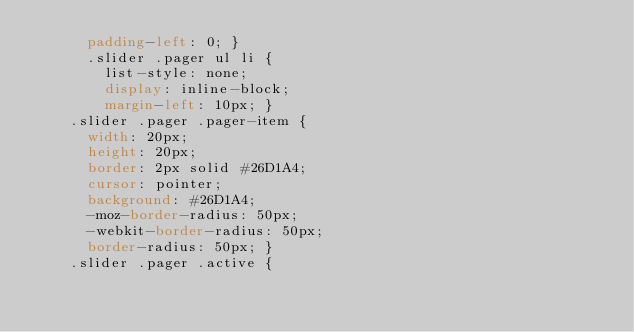Convert code to text. <code><loc_0><loc_0><loc_500><loc_500><_CSS_>      padding-left: 0; }
      .slider .pager ul li {
        list-style: none;
        display: inline-block;
        margin-left: 10px; }
    .slider .pager .pager-item {
      width: 20px;
      height: 20px;
      border: 2px solid #26D1A4;
      cursor: pointer;
      background: #26D1A4;
      -moz-border-radius: 50px;
      -webkit-border-radius: 50px;
      border-radius: 50px; }
    .slider .pager .active {</code> 